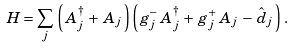<formula> <loc_0><loc_0><loc_500><loc_500>H = \sum _ { j } \, \left ( \, A ^ { \dag } _ { j } \, + \, A _ { j } \, \right ) \left ( \, g ^ { - } _ { j } \, A ^ { \dag } _ { j } \, + \, g ^ { + } _ { j } \, A _ { j } \, - \, \hat { d } _ { j } \, \right ) \, .</formula> 